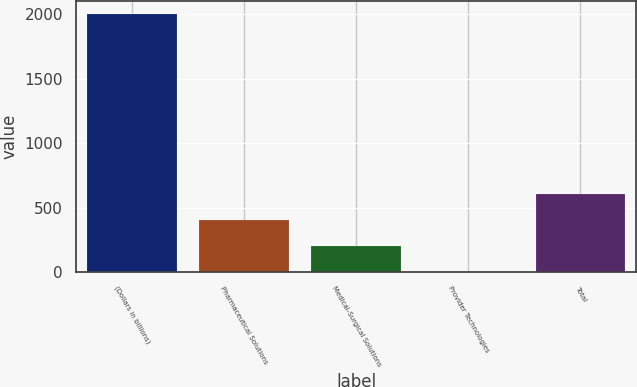Convert chart to OTSL. <chart><loc_0><loc_0><loc_500><loc_500><bar_chart><fcel>(Dollars in billions)<fcel>Pharmaceutical Solutions<fcel>Medical-Surgical Solutions<fcel>Provider Technologies<fcel>Total<nl><fcel>2004<fcel>402.4<fcel>202.2<fcel>2<fcel>602.6<nl></chart> 